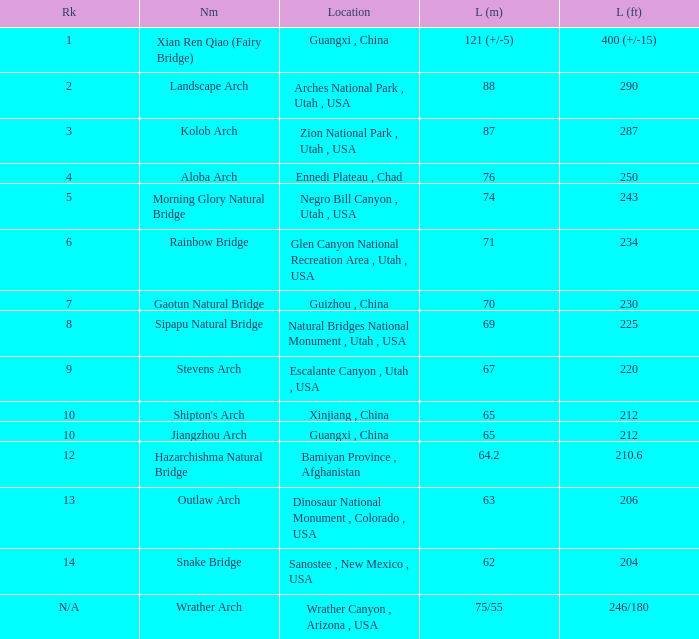Where is the longest arch measuring 6 Bamiyan Province , Afghanistan. 